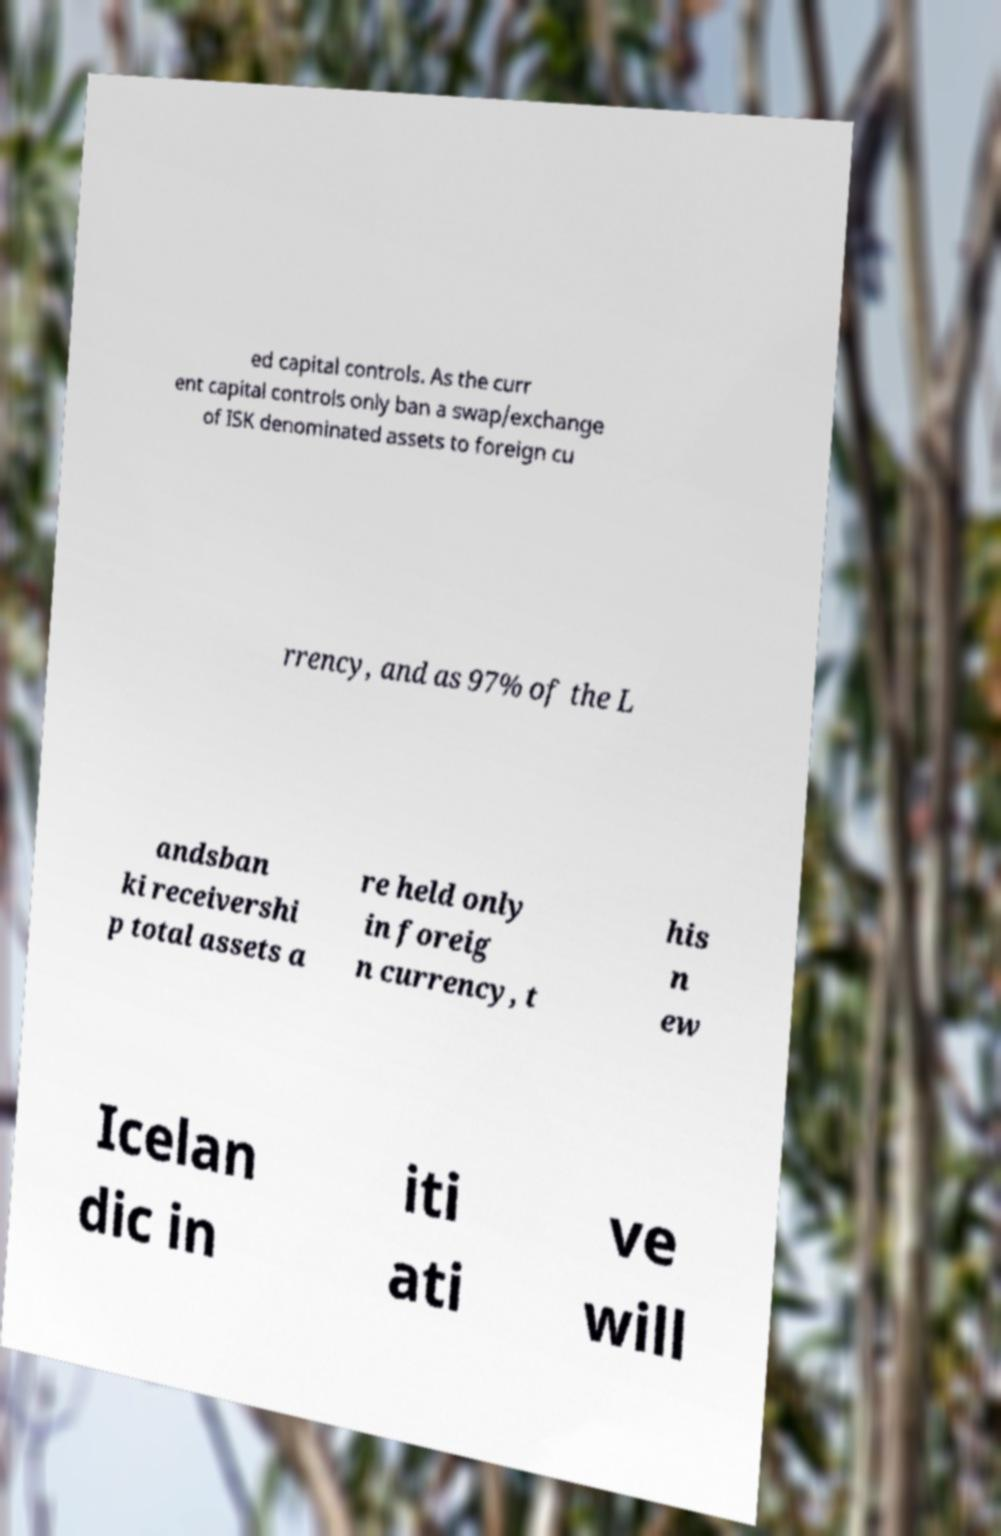Could you assist in decoding the text presented in this image and type it out clearly? ed capital controls. As the curr ent capital controls only ban a swap/exchange of ISK denominated assets to foreign cu rrency, and as 97% of the L andsban ki receivershi p total assets a re held only in foreig n currency, t his n ew Icelan dic in iti ati ve will 